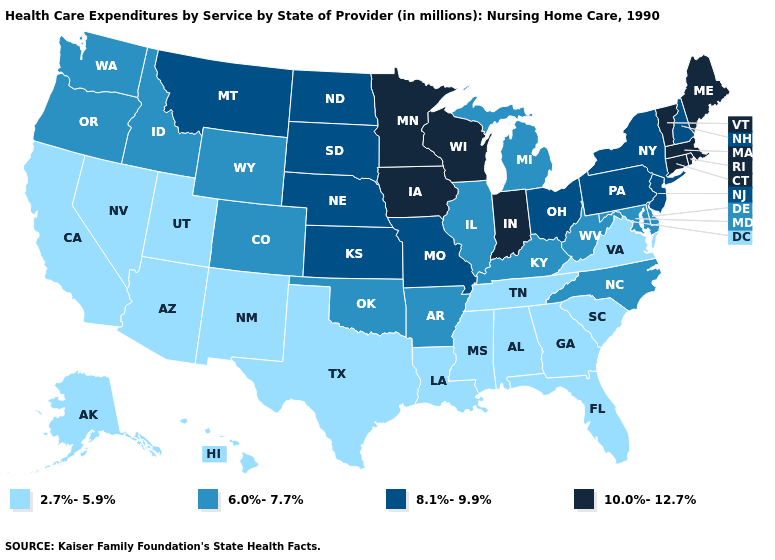What is the highest value in the USA?
Keep it brief. 10.0%-12.7%. Name the states that have a value in the range 6.0%-7.7%?
Concise answer only. Arkansas, Colorado, Delaware, Idaho, Illinois, Kentucky, Maryland, Michigan, North Carolina, Oklahoma, Oregon, Washington, West Virginia, Wyoming. Name the states that have a value in the range 6.0%-7.7%?
Give a very brief answer. Arkansas, Colorado, Delaware, Idaho, Illinois, Kentucky, Maryland, Michigan, North Carolina, Oklahoma, Oregon, Washington, West Virginia, Wyoming. Does Nevada have the same value as Texas?
Keep it brief. Yes. What is the value of Arkansas?
Quick response, please. 6.0%-7.7%. What is the lowest value in the South?
Short answer required. 2.7%-5.9%. What is the highest value in the Northeast ?
Short answer required. 10.0%-12.7%. How many symbols are there in the legend?
Quick response, please. 4. What is the value of Louisiana?
Keep it brief. 2.7%-5.9%. What is the lowest value in states that border California?
Quick response, please. 2.7%-5.9%. What is the highest value in the USA?
Quick response, please. 10.0%-12.7%. Does the first symbol in the legend represent the smallest category?
Quick response, please. Yes. Among the states that border Utah , does Nevada have the lowest value?
Answer briefly. Yes. Among the states that border New Jersey , does Delaware have the lowest value?
Write a very short answer. Yes. Which states have the lowest value in the Northeast?
Short answer required. New Hampshire, New Jersey, New York, Pennsylvania. 